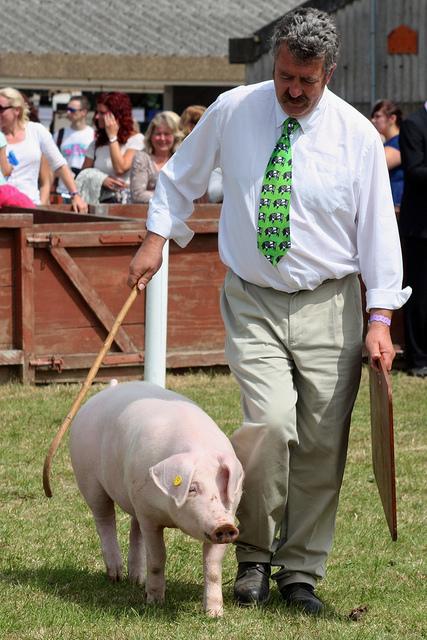What color is the man's tie?
Answer briefly. Green. What is in the man's right hand?
Keep it brief. Stick. What animal is next to the man?
Give a very brief answer. Pig. 